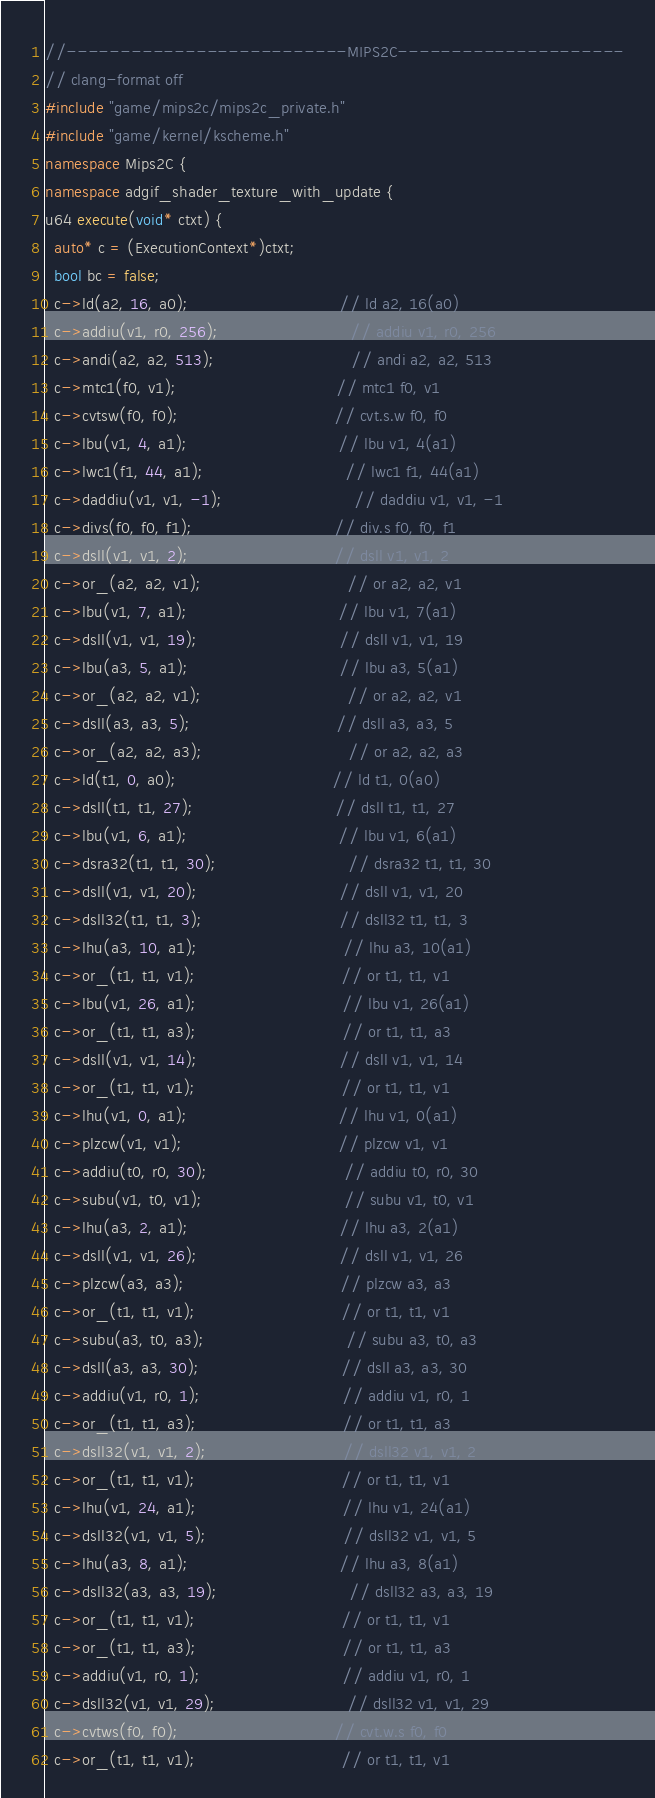Convert code to text. <code><loc_0><loc_0><loc_500><loc_500><_C++_>//--------------------------MIPS2C---------------------
// clang-format off
#include "game/mips2c/mips2c_private.h"
#include "game/kernel/kscheme.h"
namespace Mips2C {
namespace adgif_shader_texture_with_update {
u64 execute(void* ctxt) {
  auto* c = (ExecutionContext*)ctxt;
  bool bc = false;
  c->ld(a2, 16, a0);                                // ld a2, 16(a0)
  c->addiu(v1, r0, 256);                            // addiu v1, r0, 256
  c->andi(a2, a2, 513);                             // andi a2, a2, 513
  c->mtc1(f0, v1);                                  // mtc1 f0, v1
  c->cvtsw(f0, f0);                                 // cvt.s.w f0, f0
  c->lbu(v1, 4, a1);                                // lbu v1, 4(a1)
  c->lwc1(f1, 44, a1);                              // lwc1 f1, 44(a1)
  c->daddiu(v1, v1, -1);                            // daddiu v1, v1, -1
  c->divs(f0, f0, f1);                              // div.s f0, f0, f1
  c->dsll(v1, v1, 2);                               // dsll v1, v1, 2
  c->or_(a2, a2, v1);                               // or a2, a2, v1
  c->lbu(v1, 7, a1);                                // lbu v1, 7(a1)
  c->dsll(v1, v1, 19);                              // dsll v1, v1, 19
  c->lbu(a3, 5, a1);                                // lbu a3, 5(a1)
  c->or_(a2, a2, v1);                               // or a2, a2, v1
  c->dsll(a3, a3, 5);                               // dsll a3, a3, 5
  c->or_(a2, a2, a3);                               // or a2, a2, a3
  c->ld(t1, 0, a0);                                 // ld t1, 0(a0)
  c->dsll(t1, t1, 27);                              // dsll t1, t1, 27
  c->lbu(v1, 6, a1);                                // lbu v1, 6(a1)
  c->dsra32(t1, t1, 30);                            // dsra32 t1, t1, 30
  c->dsll(v1, v1, 20);                              // dsll v1, v1, 20
  c->dsll32(t1, t1, 3);                             // dsll32 t1, t1, 3
  c->lhu(a3, 10, a1);                               // lhu a3, 10(a1)
  c->or_(t1, t1, v1);                               // or t1, t1, v1
  c->lbu(v1, 26, a1);                               // lbu v1, 26(a1)
  c->or_(t1, t1, a3);                               // or t1, t1, a3
  c->dsll(v1, v1, 14);                              // dsll v1, v1, 14
  c->or_(t1, t1, v1);                               // or t1, t1, v1
  c->lhu(v1, 0, a1);                                // lhu v1, 0(a1)
  c->plzcw(v1, v1);                                 // plzcw v1, v1
  c->addiu(t0, r0, 30);                             // addiu t0, r0, 30
  c->subu(v1, t0, v1);                              // subu v1, t0, v1
  c->lhu(a3, 2, a1);                                // lhu a3, 2(a1)
  c->dsll(v1, v1, 26);                              // dsll v1, v1, 26
  c->plzcw(a3, a3);                                 // plzcw a3, a3
  c->or_(t1, t1, v1);                               // or t1, t1, v1
  c->subu(a3, t0, a3);                              // subu a3, t0, a3
  c->dsll(a3, a3, 30);                              // dsll a3, a3, 30
  c->addiu(v1, r0, 1);                              // addiu v1, r0, 1
  c->or_(t1, t1, a3);                               // or t1, t1, a3
  c->dsll32(v1, v1, 2);                             // dsll32 v1, v1, 2
  c->or_(t1, t1, v1);                               // or t1, t1, v1
  c->lhu(v1, 24, a1);                               // lhu v1, 24(a1)
  c->dsll32(v1, v1, 5);                             // dsll32 v1, v1, 5
  c->lhu(a3, 8, a1);                                // lhu a3, 8(a1)
  c->dsll32(a3, a3, 19);                            // dsll32 a3, a3, 19
  c->or_(t1, t1, v1);                               // or t1, t1, v1
  c->or_(t1, t1, a3);                               // or t1, t1, a3
  c->addiu(v1, r0, 1);                              // addiu v1, r0, 1
  c->dsll32(v1, v1, 29);                            // dsll32 v1, v1, 29
  c->cvtws(f0, f0);                                 // cvt.w.s f0, f0
  c->or_(t1, t1, v1);                               // or t1, t1, v1</code> 